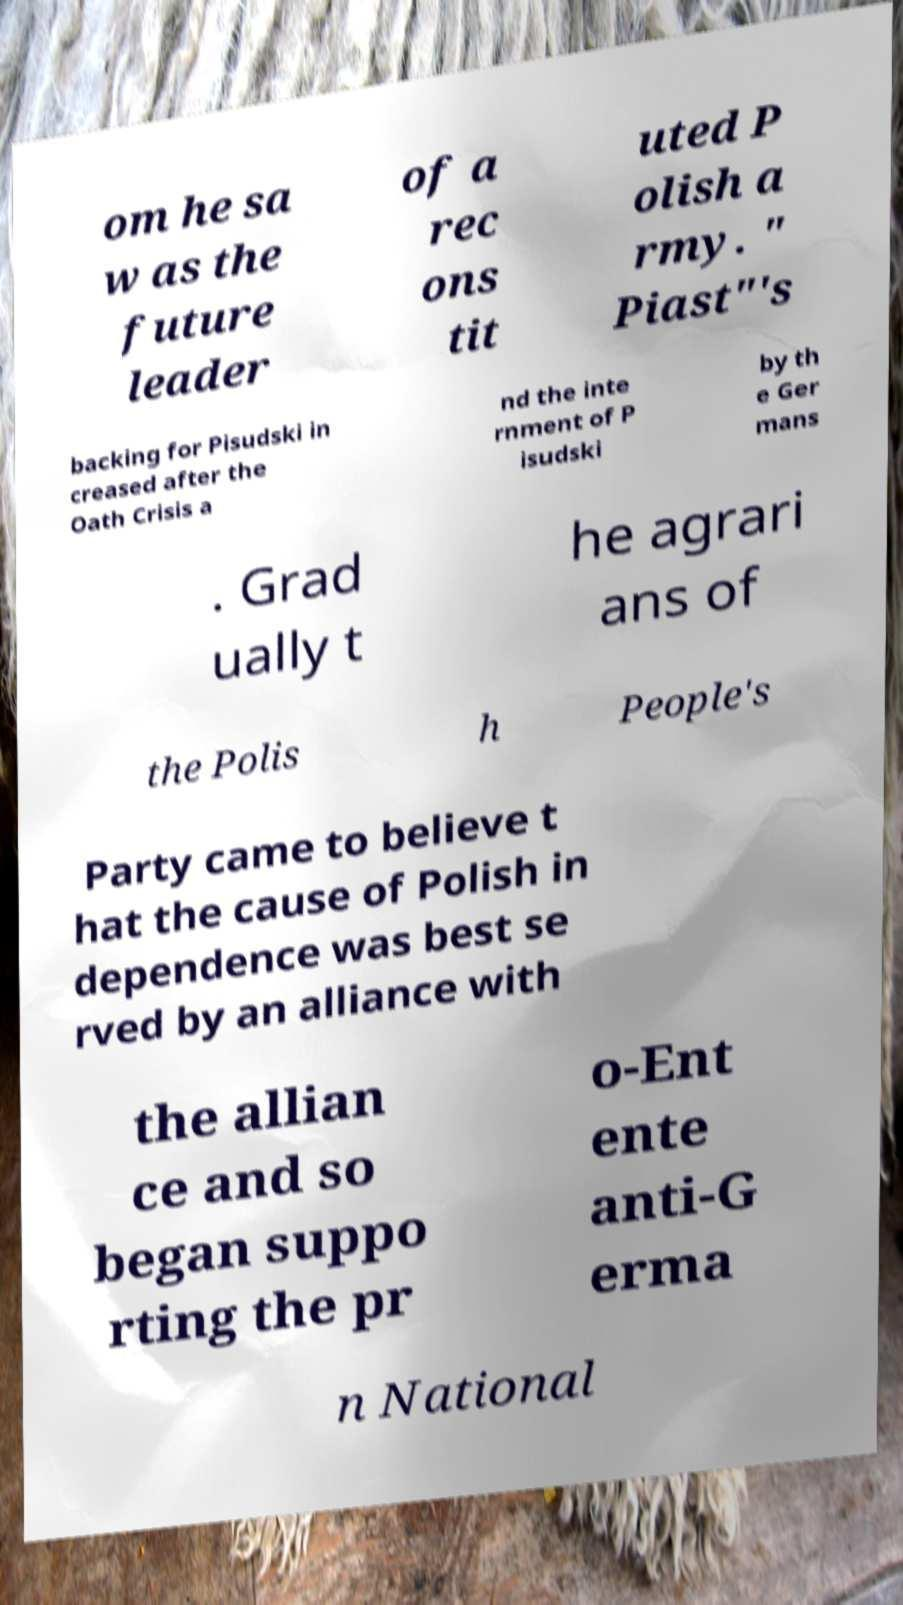Please identify and transcribe the text found in this image. om he sa w as the future leader of a rec ons tit uted P olish a rmy. " Piast"'s backing for Pisudski in creased after the Oath Crisis a nd the inte rnment of P isudski by th e Ger mans . Grad ually t he agrari ans of the Polis h People's Party came to believe t hat the cause of Polish in dependence was best se rved by an alliance with the allian ce and so began suppo rting the pr o-Ent ente anti-G erma n National 